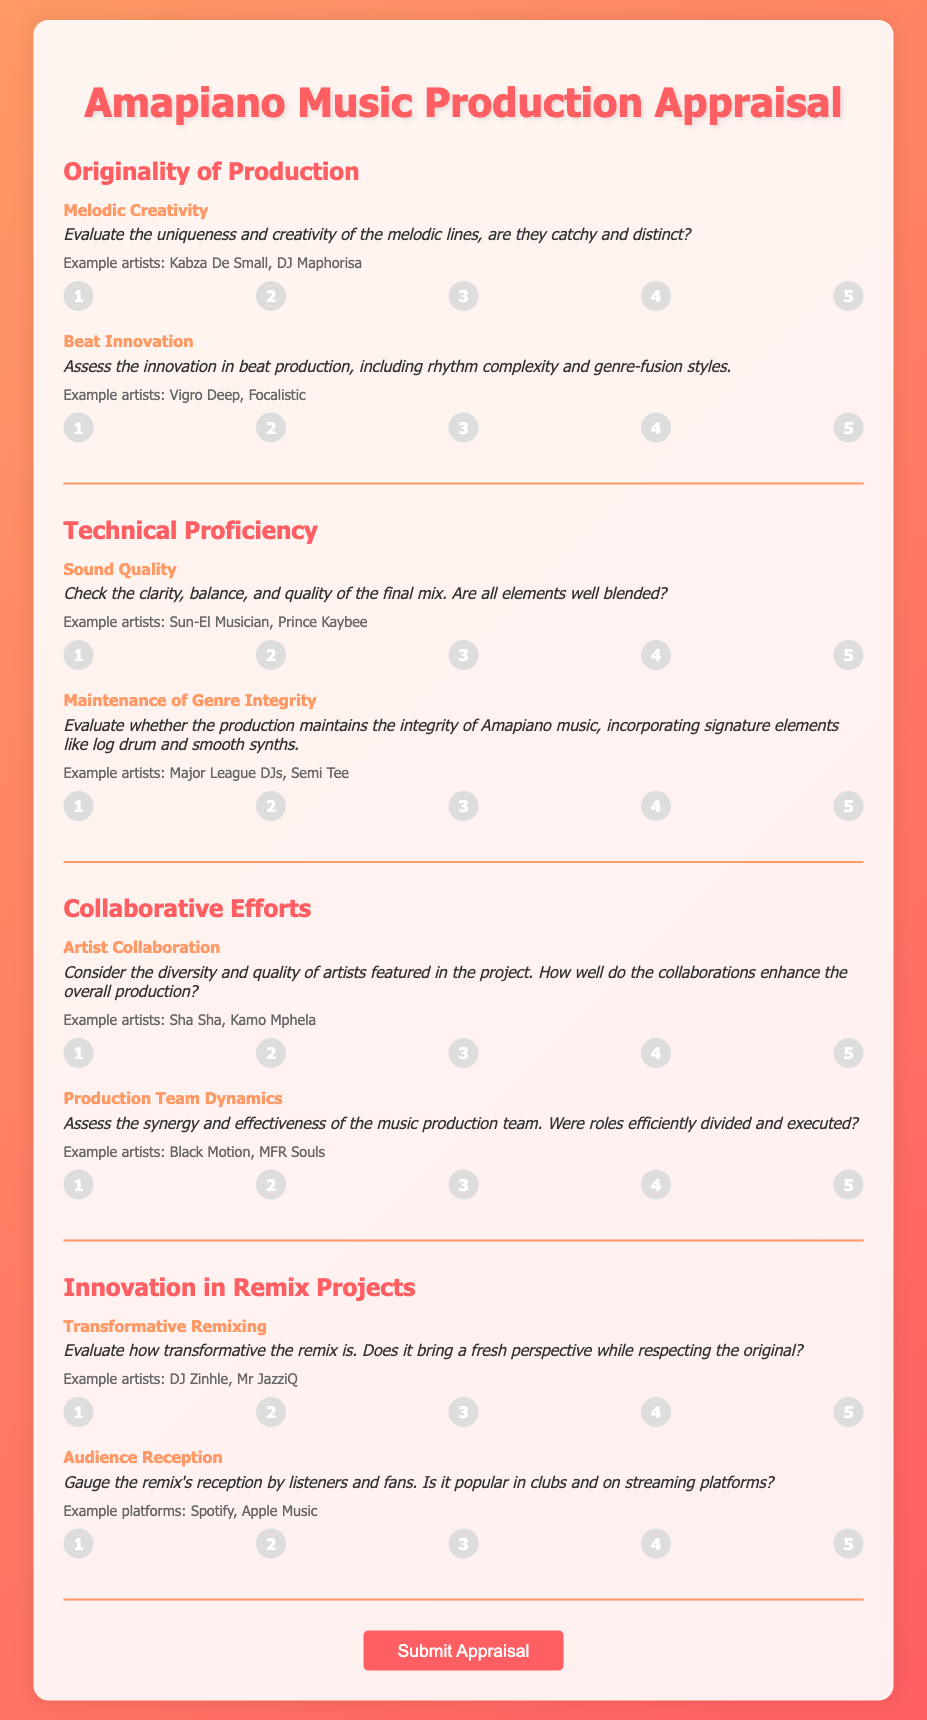What is the title of the document? The title is found in the header of the document and introduces the content.
Answer: Amapiano Music Production Appraisal Who are two example artists for Melodic Creativity? The document provides examples of artists related to each criterion, indicating their relevance to the section.
Answer: Kabza De Small, DJ Maphorisa What are the five rating options for Sound Quality? The rating options are specified in a radio button format directly under the criteria description for Sound Quality.
Answer: 1, 2, 3, 4, 5 How many criteria are listed under Technical Proficiency? The sections of the document count the criteria, allowing us to determine the number included in this specific area.
Answer: 2 What is the focus of the section titled "Innovations in Remix Projects"? The section itself titles the criteria, revealing its aim regarding remix projects and creativity.
Answer: Transformative remixing and audience reception How many example artists are listed for Production Team Dynamics? The document explicitly states the criteria and includes the example artists, indicating their number for clarity.
Answer: 2 What is the highest score a project can achieve in the appraisal? The scoring system indicates the maximum rating available for each criterion, helping to define the overall range.
Answer: 5 What does the description for Beat Innovation emphasize? The details provided in the criteria give insight into what specifically is assessed under each area.
Answer: Innovation in beat production Which section assesses Artist Collaboration? Each section is labeled, helping to identify the specific area that examines the quality of collaborations in projects.
Answer: Collaborative Efforts 